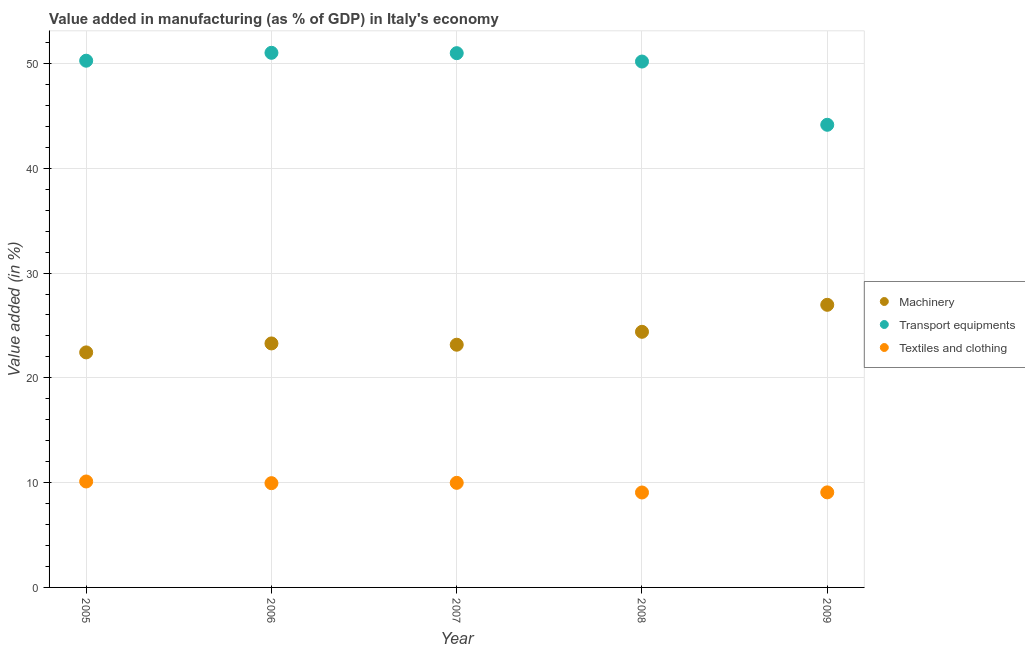How many different coloured dotlines are there?
Make the answer very short. 3. Is the number of dotlines equal to the number of legend labels?
Keep it short and to the point. Yes. What is the value added in manufacturing machinery in 2009?
Your response must be concise. 26.97. Across all years, what is the maximum value added in manufacturing transport equipments?
Provide a short and direct response. 51.02. Across all years, what is the minimum value added in manufacturing textile and clothing?
Provide a short and direct response. 9.06. What is the total value added in manufacturing machinery in the graph?
Give a very brief answer. 120.24. What is the difference between the value added in manufacturing transport equipments in 2007 and that in 2009?
Your response must be concise. 6.83. What is the difference between the value added in manufacturing textile and clothing in 2006 and the value added in manufacturing transport equipments in 2008?
Ensure brevity in your answer.  -40.24. What is the average value added in manufacturing machinery per year?
Provide a short and direct response. 24.05. In the year 2009, what is the difference between the value added in manufacturing transport equipments and value added in manufacturing machinery?
Ensure brevity in your answer.  17.18. What is the ratio of the value added in manufacturing transport equipments in 2005 to that in 2006?
Make the answer very short. 0.99. What is the difference between the highest and the second highest value added in manufacturing machinery?
Keep it short and to the point. 2.58. What is the difference between the highest and the lowest value added in manufacturing transport equipments?
Provide a succinct answer. 6.87. Is the sum of the value added in manufacturing machinery in 2006 and 2008 greater than the maximum value added in manufacturing transport equipments across all years?
Give a very brief answer. No. Does the value added in manufacturing textile and clothing monotonically increase over the years?
Your answer should be very brief. No. Are the values on the major ticks of Y-axis written in scientific E-notation?
Ensure brevity in your answer.  No. Does the graph contain grids?
Make the answer very short. Yes. How are the legend labels stacked?
Your answer should be compact. Vertical. What is the title of the graph?
Make the answer very short. Value added in manufacturing (as % of GDP) in Italy's economy. Does "Fuel" appear as one of the legend labels in the graph?
Ensure brevity in your answer.  No. What is the label or title of the Y-axis?
Make the answer very short. Value added (in %). What is the Value added (in %) of Machinery in 2005?
Give a very brief answer. 22.43. What is the Value added (in %) in Transport equipments in 2005?
Your answer should be very brief. 50.27. What is the Value added (in %) of Textiles and clothing in 2005?
Your answer should be very brief. 10.11. What is the Value added (in %) of Machinery in 2006?
Offer a very short reply. 23.28. What is the Value added (in %) in Transport equipments in 2006?
Offer a terse response. 51.02. What is the Value added (in %) in Textiles and clothing in 2006?
Your answer should be very brief. 9.95. What is the Value added (in %) in Machinery in 2007?
Provide a short and direct response. 23.16. What is the Value added (in %) in Transport equipments in 2007?
Your answer should be compact. 50.99. What is the Value added (in %) in Textiles and clothing in 2007?
Your response must be concise. 9.98. What is the Value added (in %) in Machinery in 2008?
Offer a terse response. 24.39. What is the Value added (in %) in Transport equipments in 2008?
Offer a terse response. 50.19. What is the Value added (in %) of Textiles and clothing in 2008?
Keep it short and to the point. 9.06. What is the Value added (in %) of Machinery in 2009?
Keep it short and to the point. 26.97. What is the Value added (in %) of Transport equipments in 2009?
Provide a short and direct response. 44.15. What is the Value added (in %) of Textiles and clothing in 2009?
Give a very brief answer. 9.07. Across all years, what is the maximum Value added (in %) in Machinery?
Offer a terse response. 26.97. Across all years, what is the maximum Value added (in %) of Transport equipments?
Make the answer very short. 51.02. Across all years, what is the maximum Value added (in %) of Textiles and clothing?
Your answer should be very brief. 10.11. Across all years, what is the minimum Value added (in %) of Machinery?
Make the answer very short. 22.43. Across all years, what is the minimum Value added (in %) of Transport equipments?
Provide a short and direct response. 44.15. Across all years, what is the minimum Value added (in %) in Textiles and clothing?
Offer a terse response. 9.06. What is the total Value added (in %) in Machinery in the graph?
Your answer should be compact. 120.24. What is the total Value added (in %) of Transport equipments in the graph?
Your answer should be very brief. 246.61. What is the total Value added (in %) of Textiles and clothing in the graph?
Provide a short and direct response. 48.17. What is the difference between the Value added (in %) of Machinery in 2005 and that in 2006?
Provide a short and direct response. -0.85. What is the difference between the Value added (in %) in Transport equipments in 2005 and that in 2006?
Offer a very short reply. -0.75. What is the difference between the Value added (in %) of Textiles and clothing in 2005 and that in 2006?
Your answer should be compact. 0.16. What is the difference between the Value added (in %) of Machinery in 2005 and that in 2007?
Ensure brevity in your answer.  -0.73. What is the difference between the Value added (in %) of Transport equipments in 2005 and that in 2007?
Your answer should be very brief. -0.72. What is the difference between the Value added (in %) of Textiles and clothing in 2005 and that in 2007?
Ensure brevity in your answer.  0.13. What is the difference between the Value added (in %) in Machinery in 2005 and that in 2008?
Your response must be concise. -1.96. What is the difference between the Value added (in %) in Transport equipments in 2005 and that in 2008?
Make the answer very short. 0.08. What is the difference between the Value added (in %) of Textiles and clothing in 2005 and that in 2008?
Keep it short and to the point. 1.05. What is the difference between the Value added (in %) in Machinery in 2005 and that in 2009?
Keep it short and to the point. -4.54. What is the difference between the Value added (in %) of Transport equipments in 2005 and that in 2009?
Your response must be concise. 6.12. What is the difference between the Value added (in %) of Textiles and clothing in 2005 and that in 2009?
Offer a terse response. 1.04. What is the difference between the Value added (in %) in Machinery in 2006 and that in 2007?
Ensure brevity in your answer.  0.12. What is the difference between the Value added (in %) in Transport equipments in 2006 and that in 2007?
Ensure brevity in your answer.  0.03. What is the difference between the Value added (in %) in Textiles and clothing in 2006 and that in 2007?
Provide a succinct answer. -0.03. What is the difference between the Value added (in %) of Machinery in 2006 and that in 2008?
Make the answer very short. -1.11. What is the difference between the Value added (in %) of Transport equipments in 2006 and that in 2008?
Provide a short and direct response. 0.83. What is the difference between the Value added (in %) of Textiles and clothing in 2006 and that in 2008?
Your answer should be very brief. 0.89. What is the difference between the Value added (in %) of Machinery in 2006 and that in 2009?
Provide a short and direct response. -3.69. What is the difference between the Value added (in %) of Transport equipments in 2006 and that in 2009?
Provide a short and direct response. 6.87. What is the difference between the Value added (in %) in Textiles and clothing in 2006 and that in 2009?
Make the answer very short. 0.88. What is the difference between the Value added (in %) in Machinery in 2007 and that in 2008?
Your answer should be very brief. -1.23. What is the difference between the Value added (in %) of Transport equipments in 2007 and that in 2008?
Provide a succinct answer. 0.8. What is the difference between the Value added (in %) of Textiles and clothing in 2007 and that in 2008?
Provide a short and direct response. 0.92. What is the difference between the Value added (in %) in Machinery in 2007 and that in 2009?
Provide a short and direct response. -3.81. What is the difference between the Value added (in %) in Transport equipments in 2007 and that in 2009?
Keep it short and to the point. 6.83. What is the difference between the Value added (in %) in Machinery in 2008 and that in 2009?
Provide a short and direct response. -2.58. What is the difference between the Value added (in %) of Transport equipments in 2008 and that in 2009?
Keep it short and to the point. 6.04. What is the difference between the Value added (in %) in Textiles and clothing in 2008 and that in 2009?
Offer a terse response. -0.01. What is the difference between the Value added (in %) in Machinery in 2005 and the Value added (in %) in Transport equipments in 2006?
Provide a short and direct response. -28.59. What is the difference between the Value added (in %) of Machinery in 2005 and the Value added (in %) of Textiles and clothing in 2006?
Provide a succinct answer. 12.48. What is the difference between the Value added (in %) of Transport equipments in 2005 and the Value added (in %) of Textiles and clothing in 2006?
Provide a succinct answer. 40.32. What is the difference between the Value added (in %) of Machinery in 2005 and the Value added (in %) of Transport equipments in 2007?
Give a very brief answer. -28.56. What is the difference between the Value added (in %) of Machinery in 2005 and the Value added (in %) of Textiles and clothing in 2007?
Your answer should be very brief. 12.45. What is the difference between the Value added (in %) of Transport equipments in 2005 and the Value added (in %) of Textiles and clothing in 2007?
Keep it short and to the point. 40.29. What is the difference between the Value added (in %) in Machinery in 2005 and the Value added (in %) in Transport equipments in 2008?
Provide a succinct answer. -27.76. What is the difference between the Value added (in %) in Machinery in 2005 and the Value added (in %) in Textiles and clothing in 2008?
Ensure brevity in your answer.  13.37. What is the difference between the Value added (in %) in Transport equipments in 2005 and the Value added (in %) in Textiles and clothing in 2008?
Make the answer very short. 41.21. What is the difference between the Value added (in %) of Machinery in 2005 and the Value added (in %) of Transport equipments in 2009?
Your answer should be very brief. -21.72. What is the difference between the Value added (in %) in Machinery in 2005 and the Value added (in %) in Textiles and clothing in 2009?
Give a very brief answer. 13.36. What is the difference between the Value added (in %) in Transport equipments in 2005 and the Value added (in %) in Textiles and clothing in 2009?
Make the answer very short. 41.19. What is the difference between the Value added (in %) in Machinery in 2006 and the Value added (in %) in Transport equipments in 2007?
Make the answer very short. -27.7. What is the difference between the Value added (in %) of Machinery in 2006 and the Value added (in %) of Textiles and clothing in 2007?
Your answer should be very brief. 13.3. What is the difference between the Value added (in %) in Transport equipments in 2006 and the Value added (in %) in Textiles and clothing in 2007?
Offer a very short reply. 41.04. What is the difference between the Value added (in %) of Machinery in 2006 and the Value added (in %) of Transport equipments in 2008?
Ensure brevity in your answer.  -26.9. What is the difference between the Value added (in %) of Machinery in 2006 and the Value added (in %) of Textiles and clothing in 2008?
Keep it short and to the point. 14.22. What is the difference between the Value added (in %) of Transport equipments in 2006 and the Value added (in %) of Textiles and clothing in 2008?
Make the answer very short. 41.96. What is the difference between the Value added (in %) in Machinery in 2006 and the Value added (in %) in Transport equipments in 2009?
Provide a short and direct response. -20.87. What is the difference between the Value added (in %) of Machinery in 2006 and the Value added (in %) of Textiles and clothing in 2009?
Offer a very short reply. 14.21. What is the difference between the Value added (in %) of Transport equipments in 2006 and the Value added (in %) of Textiles and clothing in 2009?
Make the answer very short. 41.95. What is the difference between the Value added (in %) in Machinery in 2007 and the Value added (in %) in Transport equipments in 2008?
Your answer should be compact. -27.02. What is the difference between the Value added (in %) in Machinery in 2007 and the Value added (in %) in Textiles and clothing in 2008?
Your answer should be very brief. 14.1. What is the difference between the Value added (in %) in Transport equipments in 2007 and the Value added (in %) in Textiles and clothing in 2008?
Provide a short and direct response. 41.93. What is the difference between the Value added (in %) in Machinery in 2007 and the Value added (in %) in Transport equipments in 2009?
Give a very brief answer. -20.99. What is the difference between the Value added (in %) of Machinery in 2007 and the Value added (in %) of Textiles and clothing in 2009?
Your answer should be compact. 14.09. What is the difference between the Value added (in %) of Transport equipments in 2007 and the Value added (in %) of Textiles and clothing in 2009?
Your response must be concise. 41.91. What is the difference between the Value added (in %) in Machinery in 2008 and the Value added (in %) in Transport equipments in 2009?
Ensure brevity in your answer.  -19.76. What is the difference between the Value added (in %) in Machinery in 2008 and the Value added (in %) in Textiles and clothing in 2009?
Ensure brevity in your answer.  15.32. What is the difference between the Value added (in %) of Transport equipments in 2008 and the Value added (in %) of Textiles and clothing in 2009?
Ensure brevity in your answer.  41.11. What is the average Value added (in %) of Machinery per year?
Keep it short and to the point. 24.05. What is the average Value added (in %) in Transport equipments per year?
Provide a succinct answer. 49.32. What is the average Value added (in %) of Textiles and clothing per year?
Offer a very short reply. 9.63. In the year 2005, what is the difference between the Value added (in %) of Machinery and Value added (in %) of Transport equipments?
Your response must be concise. -27.84. In the year 2005, what is the difference between the Value added (in %) in Machinery and Value added (in %) in Textiles and clothing?
Keep it short and to the point. 12.32. In the year 2005, what is the difference between the Value added (in %) in Transport equipments and Value added (in %) in Textiles and clothing?
Your answer should be very brief. 40.16. In the year 2006, what is the difference between the Value added (in %) of Machinery and Value added (in %) of Transport equipments?
Make the answer very short. -27.74. In the year 2006, what is the difference between the Value added (in %) in Machinery and Value added (in %) in Textiles and clothing?
Offer a very short reply. 13.33. In the year 2006, what is the difference between the Value added (in %) in Transport equipments and Value added (in %) in Textiles and clothing?
Your answer should be very brief. 41.07. In the year 2007, what is the difference between the Value added (in %) in Machinery and Value added (in %) in Transport equipments?
Ensure brevity in your answer.  -27.82. In the year 2007, what is the difference between the Value added (in %) in Machinery and Value added (in %) in Textiles and clothing?
Offer a very short reply. 13.18. In the year 2007, what is the difference between the Value added (in %) in Transport equipments and Value added (in %) in Textiles and clothing?
Provide a short and direct response. 41. In the year 2008, what is the difference between the Value added (in %) of Machinery and Value added (in %) of Transport equipments?
Keep it short and to the point. -25.79. In the year 2008, what is the difference between the Value added (in %) in Machinery and Value added (in %) in Textiles and clothing?
Your answer should be compact. 15.33. In the year 2008, what is the difference between the Value added (in %) in Transport equipments and Value added (in %) in Textiles and clothing?
Your answer should be compact. 41.13. In the year 2009, what is the difference between the Value added (in %) of Machinery and Value added (in %) of Transport equipments?
Your response must be concise. -17.18. In the year 2009, what is the difference between the Value added (in %) of Machinery and Value added (in %) of Textiles and clothing?
Give a very brief answer. 17.9. In the year 2009, what is the difference between the Value added (in %) of Transport equipments and Value added (in %) of Textiles and clothing?
Keep it short and to the point. 35.08. What is the ratio of the Value added (in %) in Machinery in 2005 to that in 2006?
Provide a short and direct response. 0.96. What is the ratio of the Value added (in %) of Transport equipments in 2005 to that in 2006?
Your response must be concise. 0.99. What is the ratio of the Value added (in %) in Textiles and clothing in 2005 to that in 2006?
Offer a terse response. 1.02. What is the ratio of the Value added (in %) of Machinery in 2005 to that in 2007?
Keep it short and to the point. 0.97. What is the ratio of the Value added (in %) in Transport equipments in 2005 to that in 2007?
Your response must be concise. 0.99. What is the ratio of the Value added (in %) of Machinery in 2005 to that in 2008?
Ensure brevity in your answer.  0.92. What is the ratio of the Value added (in %) in Textiles and clothing in 2005 to that in 2008?
Offer a terse response. 1.12. What is the ratio of the Value added (in %) of Machinery in 2005 to that in 2009?
Keep it short and to the point. 0.83. What is the ratio of the Value added (in %) in Transport equipments in 2005 to that in 2009?
Provide a succinct answer. 1.14. What is the ratio of the Value added (in %) in Textiles and clothing in 2005 to that in 2009?
Make the answer very short. 1.11. What is the ratio of the Value added (in %) in Machinery in 2006 to that in 2008?
Give a very brief answer. 0.95. What is the ratio of the Value added (in %) in Transport equipments in 2006 to that in 2008?
Give a very brief answer. 1.02. What is the ratio of the Value added (in %) of Textiles and clothing in 2006 to that in 2008?
Provide a short and direct response. 1.1. What is the ratio of the Value added (in %) in Machinery in 2006 to that in 2009?
Offer a terse response. 0.86. What is the ratio of the Value added (in %) of Transport equipments in 2006 to that in 2009?
Offer a terse response. 1.16. What is the ratio of the Value added (in %) of Textiles and clothing in 2006 to that in 2009?
Ensure brevity in your answer.  1.1. What is the ratio of the Value added (in %) of Machinery in 2007 to that in 2008?
Your answer should be very brief. 0.95. What is the ratio of the Value added (in %) in Transport equipments in 2007 to that in 2008?
Your answer should be compact. 1.02. What is the ratio of the Value added (in %) of Textiles and clothing in 2007 to that in 2008?
Offer a terse response. 1.1. What is the ratio of the Value added (in %) in Machinery in 2007 to that in 2009?
Your response must be concise. 0.86. What is the ratio of the Value added (in %) of Transport equipments in 2007 to that in 2009?
Provide a succinct answer. 1.15. What is the ratio of the Value added (in %) of Textiles and clothing in 2007 to that in 2009?
Offer a very short reply. 1.1. What is the ratio of the Value added (in %) in Machinery in 2008 to that in 2009?
Make the answer very short. 0.9. What is the ratio of the Value added (in %) in Transport equipments in 2008 to that in 2009?
Your answer should be very brief. 1.14. What is the difference between the highest and the second highest Value added (in %) of Machinery?
Offer a terse response. 2.58. What is the difference between the highest and the second highest Value added (in %) of Transport equipments?
Give a very brief answer. 0.03. What is the difference between the highest and the second highest Value added (in %) in Textiles and clothing?
Keep it short and to the point. 0.13. What is the difference between the highest and the lowest Value added (in %) of Machinery?
Provide a short and direct response. 4.54. What is the difference between the highest and the lowest Value added (in %) of Transport equipments?
Your answer should be compact. 6.87. What is the difference between the highest and the lowest Value added (in %) of Textiles and clothing?
Provide a short and direct response. 1.05. 